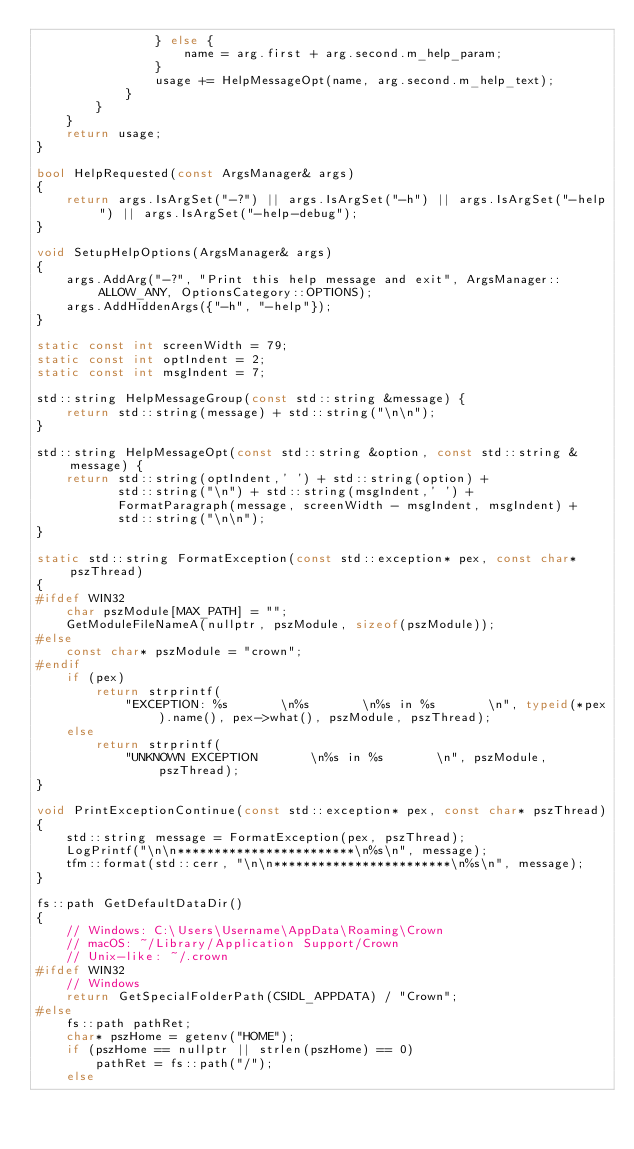<code> <loc_0><loc_0><loc_500><loc_500><_C++_>                } else {
                    name = arg.first + arg.second.m_help_param;
                }
                usage += HelpMessageOpt(name, arg.second.m_help_text);
            }
        }
    }
    return usage;
}

bool HelpRequested(const ArgsManager& args)
{
    return args.IsArgSet("-?") || args.IsArgSet("-h") || args.IsArgSet("-help") || args.IsArgSet("-help-debug");
}

void SetupHelpOptions(ArgsManager& args)
{
    args.AddArg("-?", "Print this help message and exit", ArgsManager::ALLOW_ANY, OptionsCategory::OPTIONS);
    args.AddHiddenArgs({"-h", "-help"});
}

static const int screenWidth = 79;
static const int optIndent = 2;
static const int msgIndent = 7;

std::string HelpMessageGroup(const std::string &message) {
    return std::string(message) + std::string("\n\n");
}

std::string HelpMessageOpt(const std::string &option, const std::string &message) {
    return std::string(optIndent,' ') + std::string(option) +
           std::string("\n") + std::string(msgIndent,' ') +
           FormatParagraph(message, screenWidth - msgIndent, msgIndent) +
           std::string("\n\n");
}

static std::string FormatException(const std::exception* pex, const char* pszThread)
{
#ifdef WIN32
    char pszModule[MAX_PATH] = "";
    GetModuleFileNameA(nullptr, pszModule, sizeof(pszModule));
#else
    const char* pszModule = "crown";
#endif
    if (pex)
        return strprintf(
            "EXCEPTION: %s       \n%s       \n%s in %s       \n", typeid(*pex).name(), pex->what(), pszModule, pszThread);
    else
        return strprintf(
            "UNKNOWN EXCEPTION       \n%s in %s       \n", pszModule, pszThread);
}

void PrintExceptionContinue(const std::exception* pex, const char* pszThread)
{
    std::string message = FormatException(pex, pszThread);
    LogPrintf("\n\n************************\n%s\n", message);
    tfm::format(std::cerr, "\n\n************************\n%s\n", message);
}

fs::path GetDefaultDataDir()
{
    // Windows: C:\Users\Username\AppData\Roaming\Crown
    // macOS: ~/Library/Application Support/Crown
    // Unix-like: ~/.crown
#ifdef WIN32
    // Windows
    return GetSpecialFolderPath(CSIDL_APPDATA) / "Crown";
#else
    fs::path pathRet;
    char* pszHome = getenv("HOME");
    if (pszHome == nullptr || strlen(pszHome) == 0)
        pathRet = fs::path("/");
    else</code> 